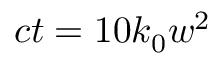<formula> <loc_0><loc_0><loc_500><loc_500>c t = 1 0 k _ { 0 } w ^ { 2 }</formula> 